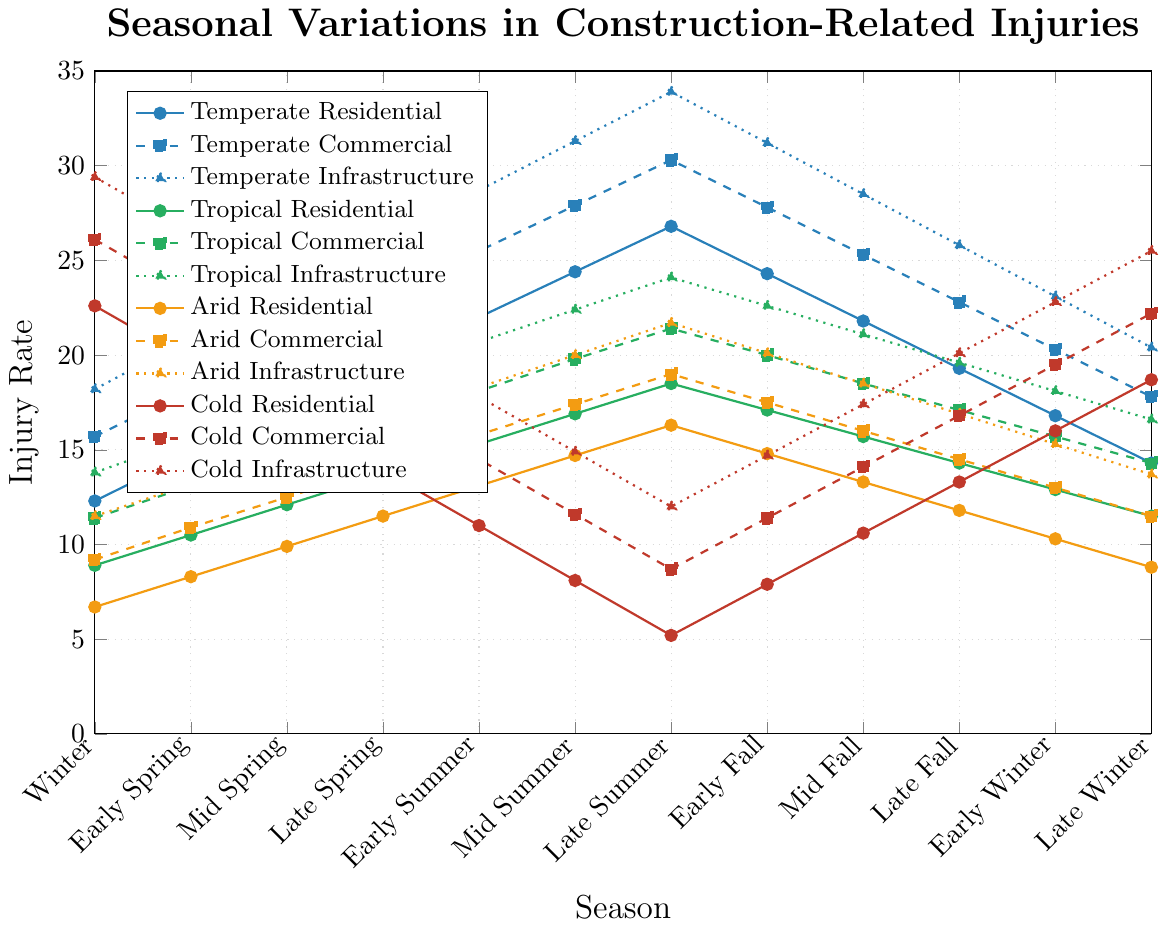What season has the highest injury rate in Tropical Infrastructure projects? Look for the peak value in the Tropical Infrastructure line (green dotted line with triangle markers). The highest value is 24.1 in Late Summer.
Answer: Late Summer Which type of project in the Temperate climate zone has the greatest increase in injury rate from Early Winter to Late Summer? Identify the values for Early Winter and Late Summer for all temperate projects. For Residential: 16.8 to 26.8 (10.0 increase), Commercial: 20.3 to 30.3 (10.0 increase), Infrastructure: 23.1 to 33.9 (10.8 increase). The highest increase is observed in Infrastructure.
Answer: Infrastructure What is the difference in the highest injury rate between Cold Commercial and Cold Infrastructure projects? Identify the highest values for each project. Cold Commercial's highest value is 26.1 (Winter), Cold Infrastructure's highest value is 29.4 (Winter). Compute the difference: 29.4 - 26.1 = 3.3.
Answer: 3.3 During Early Spring, which type of project has the lowest injury rates in the different climate zones? Check the Early Spring values for each project type in all climate zones. Residential: Temperate-14.8, Tropical-10.5, Arid-8.3, Cold-19.7. Commercial: Temperate-18.2, Tropical-13.1, Arid-10.9, Cold-23.2. Infrastructure: Temperate-20.9, Tropical-15.6, Arid-13.2, Cold-26.5. The lowest is Arid Residential.
Answer: Arid Residential Compare the injury rates for Cold Residential projects between Late Summer and Mid Winter. How much do injury rates increase or decrease? Locate Cold Residential values for Late Summer (5.2) and Mid Winter (18.7). Compute the increase: 18.7 - 5.2 = 13.5.
Answer: 13.5 increase Which season shows the least variation in injury rates across all project types in the Temperate climate zone? Find the season where the difference between the highest and lowest values is minimal for the Temperate projects. Winter: 18.2 - 12.3 = 5.9, Early Spring: 20.9 - 14.8 = 6.1, Mid Spring: 23.5 - 17.2 = 6.3, Late Spring: 26.1 - 19.6 = 6.5, Early Summer: 28.7 - 22.0 = 6.7, Mid Summer: 31.3 - 24.4 = 6.9, Late Summer: 33.9 - 26.8 = 7.1, Early Fall: 31.2 - 24.3 = 6.9, Mid Fall: 28.5 - 21.8 = 6.7, Late Fall: 25.8 - 19.3 = 6.5, Early Winter: 23.1 - 16.8 = 6.3, Late Winter: 20.4 - 14.3 = 6.1. Winter has the least variation (5.9).
Answer: Winter 